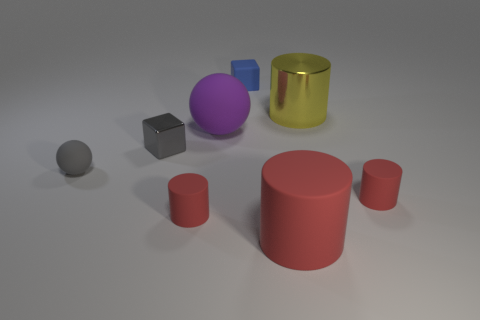Subtract all blue balls. How many red cylinders are left? 3 Subtract all large yellow shiny cylinders. How many cylinders are left? 3 Subtract 1 cylinders. How many cylinders are left? 3 Subtract all yellow cylinders. How many cylinders are left? 3 Subtract all purple cylinders. Subtract all blue balls. How many cylinders are left? 4 Add 1 big yellow metal cylinders. How many objects exist? 9 Subtract all blocks. How many objects are left? 6 Subtract 1 gray spheres. How many objects are left? 7 Subtract all large yellow metal cylinders. Subtract all cyan rubber balls. How many objects are left? 7 Add 2 big red objects. How many big red objects are left? 3 